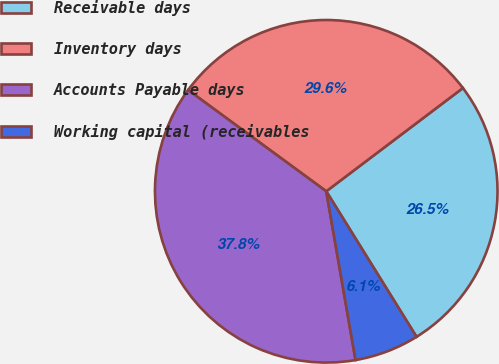Convert chart to OTSL. <chart><loc_0><loc_0><loc_500><loc_500><pie_chart><fcel>Receivable days<fcel>Inventory days<fcel>Accounts Payable days<fcel>Working capital (receivables<nl><fcel>26.46%<fcel>29.63%<fcel>37.8%<fcel>6.1%<nl></chart> 